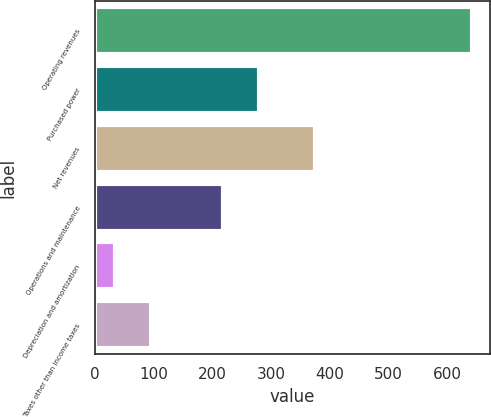Convert chart to OTSL. <chart><loc_0><loc_0><loc_500><loc_500><bar_chart><fcel>Operating revenues<fcel>Purchased power<fcel>Net revenues<fcel>Operations and maintenance<fcel>Depreciation and amortization<fcel>Taxes other than income taxes<nl><fcel>641<fcel>278.6<fcel>374<fcel>218<fcel>35<fcel>95.6<nl></chart> 